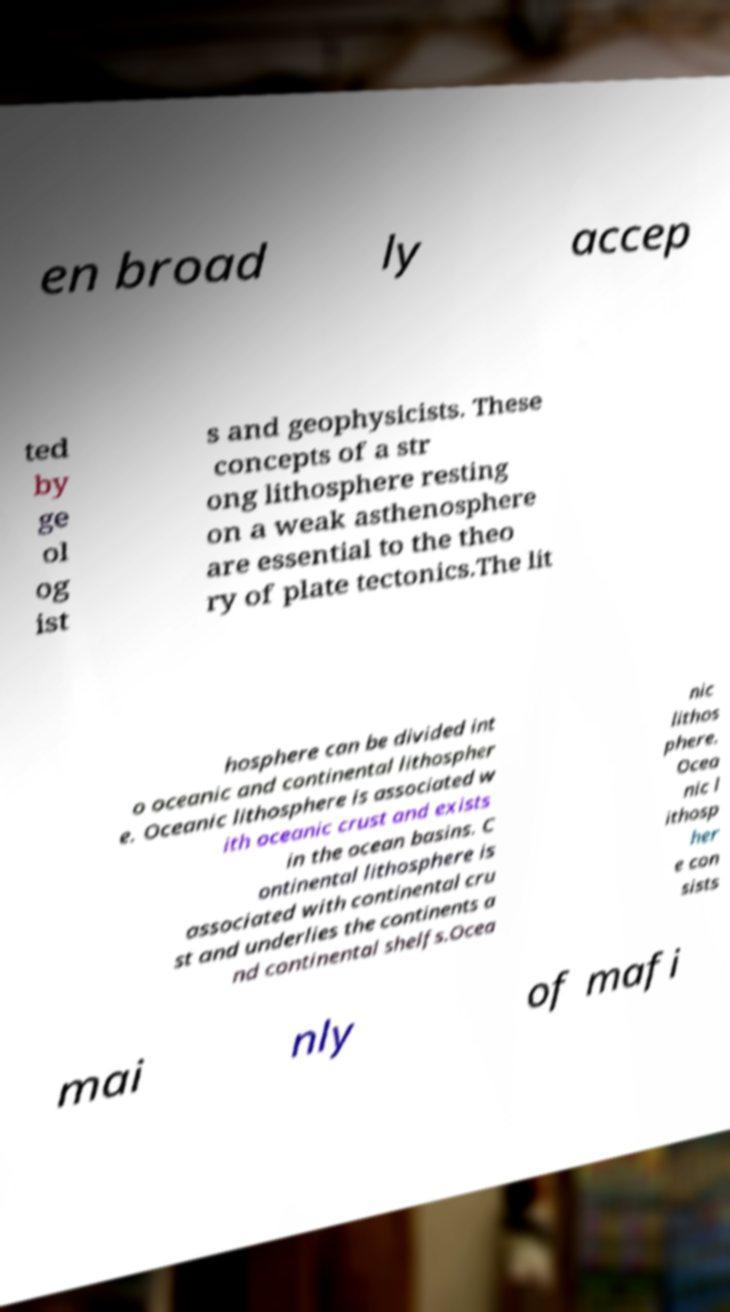Can you accurately transcribe the text from the provided image for me? en broad ly accep ted by ge ol og ist s and geophysicists. These concepts of a str ong lithosphere resting on a weak asthenosphere are essential to the theo ry of plate tectonics.The lit hosphere can be divided int o oceanic and continental lithospher e. Oceanic lithosphere is associated w ith oceanic crust and exists in the ocean basins. C ontinental lithosphere is associated with continental cru st and underlies the continents a nd continental shelfs.Ocea nic lithos phere. Ocea nic l ithosp her e con sists mai nly of mafi 